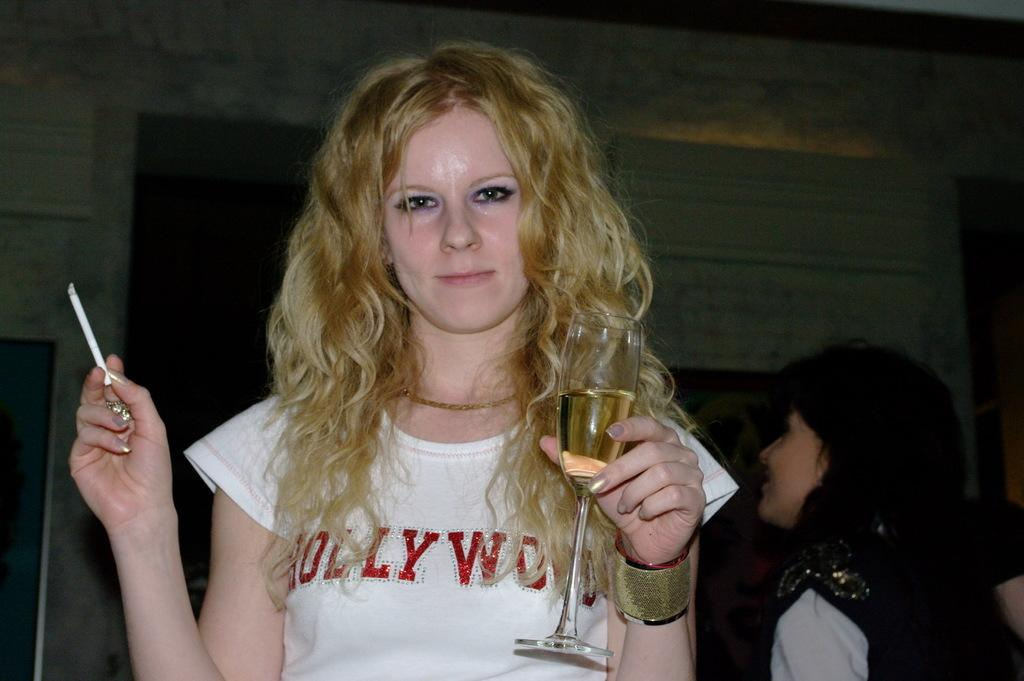What is the main subject of the image? The main subject of the image is a woman standing in the middle. What is the woman holding in her hand? The woman is holding a glass and a cigarette. Are there any other people in the image? Yes, there are people standing behind the woman. What can be seen at the top of the image? There is a wall at the top of the image. What type of joke is the woman telling in the image? There is no indication in the image that the woman is telling a joke, so it cannot be determined from the picture. 